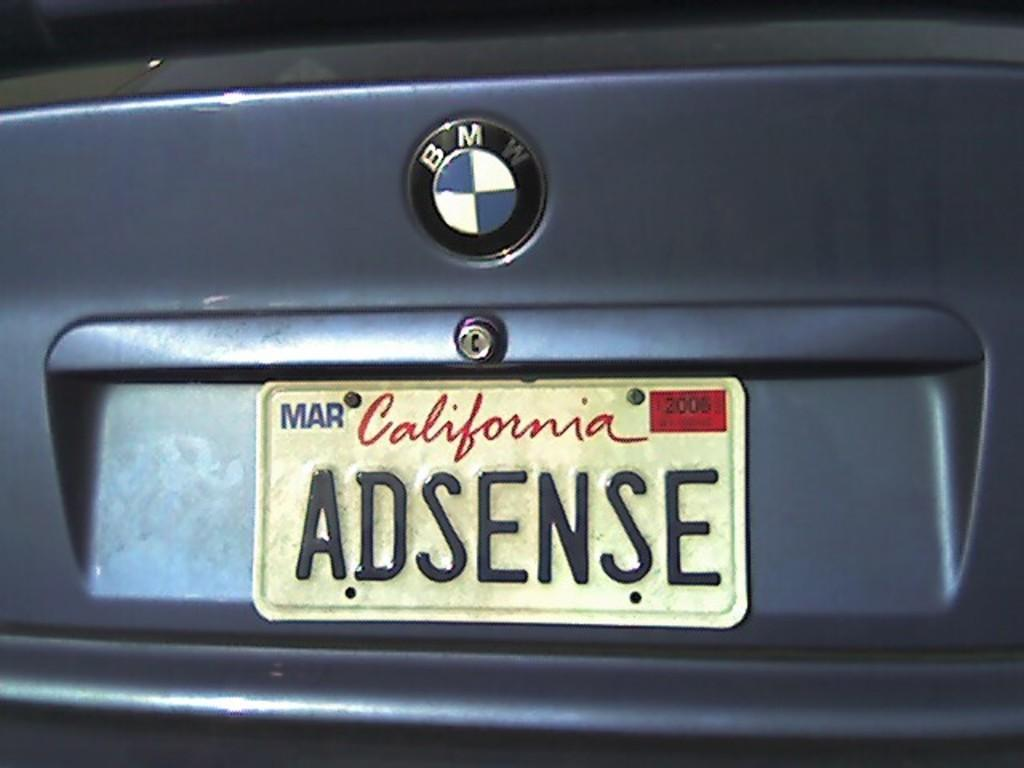<image>
Create a compact narrative representing the image presented. A BMW car has a plate that reads adsense. 